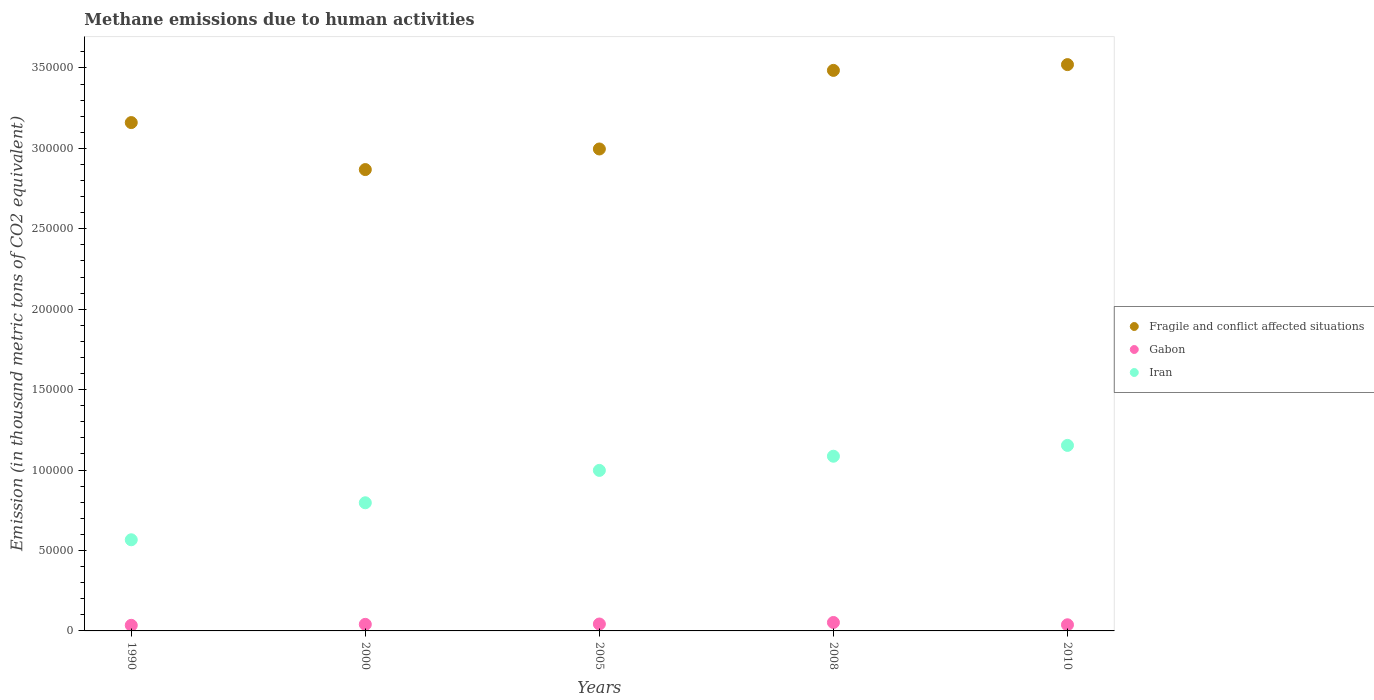Is the number of dotlines equal to the number of legend labels?
Offer a very short reply. Yes. What is the amount of methane emitted in Iran in 2000?
Provide a succinct answer. 7.97e+04. Across all years, what is the maximum amount of methane emitted in Iran?
Ensure brevity in your answer.  1.15e+05. Across all years, what is the minimum amount of methane emitted in Fragile and conflict affected situations?
Give a very brief answer. 2.87e+05. In which year was the amount of methane emitted in Iran maximum?
Your response must be concise. 2010. In which year was the amount of methane emitted in Fragile and conflict affected situations minimum?
Provide a succinct answer. 2000. What is the total amount of methane emitted in Gabon in the graph?
Your answer should be very brief. 2.09e+04. What is the difference between the amount of methane emitted in Fragile and conflict affected situations in 2000 and that in 2005?
Your answer should be very brief. -1.28e+04. What is the difference between the amount of methane emitted in Iran in 1990 and the amount of methane emitted in Gabon in 2008?
Give a very brief answer. 5.14e+04. What is the average amount of methane emitted in Gabon per year?
Your response must be concise. 4184.8. In the year 2008, what is the difference between the amount of methane emitted in Gabon and amount of methane emitted in Iran?
Your answer should be very brief. -1.03e+05. In how many years, is the amount of methane emitted in Iran greater than 200000 thousand metric tons?
Provide a short and direct response. 0. What is the ratio of the amount of methane emitted in Fragile and conflict affected situations in 1990 to that in 2010?
Your answer should be compact. 0.9. Is the amount of methane emitted in Iran in 2000 less than that in 2005?
Offer a very short reply. Yes. Is the difference between the amount of methane emitted in Gabon in 1990 and 2010 greater than the difference between the amount of methane emitted in Iran in 1990 and 2010?
Provide a short and direct response. Yes. What is the difference between the highest and the second highest amount of methane emitted in Iran?
Give a very brief answer. 6726.3. What is the difference between the highest and the lowest amount of methane emitted in Iran?
Keep it short and to the point. 5.87e+04. In how many years, is the amount of methane emitted in Fragile and conflict affected situations greater than the average amount of methane emitted in Fragile and conflict affected situations taken over all years?
Provide a succinct answer. 2. Is the sum of the amount of methane emitted in Fragile and conflict affected situations in 2005 and 2010 greater than the maximum amount of methane emitted in Iran across all years?
Your answer should be very brief. Yes. Is it the case that in every year, the sum of the amount of methane emitted in Fragile and conflict affected situations and amount of methane emitted in Iran  is greater than the amount of methane emitted in Gabon?
Make the answer very short. Yes. How many years are there in the graph?
Ensure brevity in your answer.  5. Does the graph contain any zero values?
Make the answer very short. No. Does the graph contain grids?
Provide a short and direct response. No. Where does the legend appear in the graph?
Your response must be concise. Center right. How many legend labels are there?
Your response must be concise. 3. How are the legend labels stacked?
Provide a succinct answer. Vertical. What is the title of the graph?
Provide a succinct answer. Methane emissions due to human activities. Does "Netherlands" appear as one of the legend labels in the graph?
Provide a succinct answer. No. What is the label or title of the Y-axis?
Give a very brief answer. Emission (in thousand metric tons of CO2 equivalent). What is the Emission (in thousand metric tons of CO2 equivalent) of Fragile and conflict affected situations in 1990?
Give a very brief answer. 3.16e+05. What is the Emission (in thousand metric tons of CO2 equivalent) in Gabon in 1990?
Offer a terse response. 3478.5. What is the Emission (in thousand metric tons of CO2 equivalent) in Iran in 1990?
Offer a terse response. 5.67e+04. What is the Emission (in thousand metric tons of CO2 equivalent) of Fragile and conflict affected situations in 2000?
Your answer should be compact. 2.87e+05. What is the Emission (in thousand metric tons of CO2 equivalent) in Gabon in 2000?
Offer a very short reply. 4082.1. What is the Emission (in thousand metric tons of CO2 equivalent) in Iran in 2000?
Keep it short and to the point. 7.97e+04. What is the Emission (in thousand metric tons of CO2 equivalent) of Fragile and conflict affected situations in 2005?
Offer a terse response. 3.00e+05. What is the Emission (in thousand metric tons of CO2 equivalent) of Gabon in 2005?
Make the answer very short. 4298.1. What is the Emission (in thousand metric tons of CO2 equivalent) of Iran in 2005?
Offer a terse response. 9.98e+04. What is the Emission (in thousand metric tons of CO2 equivalent) of Fragile and conflict affected situations in 2008?
Make the answer very short. 3.48e+05. What is the Emission (in thousand metric tons of CO2 equivalent) of Gabon in 2008?
Keep it short and to the point. 5247.8. What is the Emission (in thousand metric tons of CO2 equivalent) of Iran in 2008?
Provide a short and direct response. 1.09e+05. What is the Emission (in thousand metric tons of CO2 equivalent) of Fragile and conflict affected situations in 2010?
Give a very brief answer. 3.52e+05. What is the Emission (in thousand metric tons of CO2 equivalent) of Gabon in 2010?
Your answer should be very brief. 3817.5. What is the Emission (in thousand metric tons of CO2 equivalent) of Iran in 2010?
Keep it short and to the point. 1.15e+05. Across all years, what is the maximum Emission (in thousand metric tons of CO2 equivalent) in Fragile and conflict affected situations?
Your answer should be compact. 3.52e+05. Across all years, what is the maximum Emission (in thousand metric tons of CO2 equivalent) in Gabon?
Offer a terse response. 5247.8. Across all years, what is the maximum Emission (in thousand metric tons of CO2 equivalent) in Iran?
Provide a short and direct response. 1.15e+05. Across all years, what is the minimum Emission (in thousand metric tons of CO2 equivalent) in Fragile and conflict affected situations?
Provide a short and direct response. 2.87e+05. Across all years, what is the minimum Emission (in thousand metric tons of CO2 equivalent) of Gabon?
Offer a terse response. 3478.5. Across all years, what is the minimum Emission (in thousand metric tons of CO2 equivalent) in Iran?
Ensure brevity in your answer.  5.67e+04. What is the total Emission (in thousand metric tons of CO2 equivalent) in Fragile and conflict affected situations in the graph?
Offer a terse response. 1.60e+06. What is the total Emission (in thousand metric tons of CO2 equivalent) of Gabon in the graph?
Your response must be concise. 2.09e+04. What is the total Emission (in thousand metric tons of CO2 equivalent) of Iran in the graph?
Provide a succinct answer. 4.60e+05. What is the difference between the Emission (in thousand metric tons of CO2 equivalent) of Fragile and conflict affected situations in 1990 and that in 2000?
Ensure brevity in your answer.  2.92e+04. What is the difference between the Emission (in thousand metric tons of CO2 equivalent) in Gabon in 1990 and that in 2000?
Give a very brief answer. -603.6. What is the difference between the Emission (in thousand metric tons of CO2 equivalent) in Iran in 1990 and that in 2000?
Your answer should be compact. -2.30e+04. What is the difference between the Emission (in thousand metric tons of CO2 equivalent) of Fragile and conflict affected situations in 1990 and that in 2005?
Offer a very short reply. 1.64e+04. What is the difference between the Emission (in thousand metric tons of CO2 equivalent) of Gabon in 1990 and that in 2005?
Give a very brief answer. -819.6. What is the difference between the Emission (in thousand metric tons of CO2 equivalent) of Iran in 1990 and that in 2005?
Your answer should be compact. -4.31e+04. What is the difference between the Emission (in thousand metric tons of CO2 equivalent) of Fragile and conflict affected situations in 1990 and that in 2008?
Your answer should be compact. -3.24e+04. What is the difference between the Emission (in thousand metric tons of CO2 equivalent) of Gabon in 1990 and that in 2008?
Make the answer very short. -1769.3. What is the difference between the Emission (in thousand metric tons of CO2 equivalent) of Iran in 1990 and that in 2008?
Ensure brevity in your answer.  -5.19e+04. What is the difference between the Emission (in thousand metric tons of CO2 equivalent) in Fragile and conflict affected situations in 1990 and that in 2010?
Make the answer very short. -3.60e+04. What is the difference between the Emission (in thousand metric tons of CO2 equivalent) in Gabon in 1990 and that in 2010?
Provide a short and direct response. -339. What is the difference between the Emission (in thousand metric tons of CO2 equivalent) in Iran in 1990 and that in 2010?
Your response must be concise. -5.87e+04. What is the difference between the Emission (in thousand metric tons of CO2 equivalent) of Fragile and conflict affected situations in 2000 and that in 2005?
Provide a succinct answer. -1.28e+04. What is the difference between the Emission (in thousand metric tons of CO2 equivalent) of Gabon in 2000 and that in 2005?
Give a very brief answer. -216. What is the difference between the Emission (in thousand metric tons of CO2 equivalent) of Iran in 2000 and that in 2005?
Keep it short and to the point. -2.01e+04. What is the difference between the Emission (in thousand metric tons of CO2 equivalent) of Fragile and conflict affected situations in 2000 and that in 2008?
Your answer should be very brief. -6.17e+04. What is the difference between the Emission (in thousand metric tons of CO2 equivalent) of Gabon in 2000 and that in 2008?
Provide a short and direct response. -1165.7. What is the difference between the Emission (in thousand metric tons of CO2 equivalent) of Iran in 2000 and that in 2008?
Provide a short and direct response. -2.89e+04. What is the difference between the Emission (in thousand metric tons of CO2 equivalent) in Fragile and conflict affected situations in 2000 and that in 2010?
Offer a very short reply. -6.53e+04. What is the difference between the Emission (in thousand metric tons of CO2 equivalent) of Gabon in 2000 and that in 2010?
Make the answer very short. 264.6. What is the difference between the Emission (in thousand metric tons of CO2 equivalent) of Iran in 2000 and that in 2010?
Provide a succinct answer. -3.57e+04. What is the difference between the Emission (in thousand metric tons of CO2 equivalent) in Fragile and conflict affected situations in 2005 and that in 2008?
Your answer should be compact. -4.89e+04. What is the difference between the Emission (in thousand metric tons of CO2 equivalent) of Gabon in 2005 and that in 2008?
Your response must be concise. -949.7. What is the difference between the Emission (in thousand metric tons of CO2 equivalent) of Iran in 2005 and that in 2008?
Offer a terse response. -8816.1. What is the difference between the Emission (in thousand metric tons of CO2 equivalent) of Fragile and conflict affected situations in 2005 and that in 2010?
Your answer should be very brief. -5.24e+04. What is the difference between the Emission (in thousand metric tons of CO2 equivalent) in Gabon in 2005 and that in 2010?
Your answer should be very brief. 480.6. What is the difference between the Emission (in thousand metric tons of CO2 equivalent) in Iran in 2005 and that in 2010?
Your answer should be very brief. -1.55e+04. What is the difference between the Emission (in thousand metric tons of CO2 equivalent) of Fragile and conflict affected situations in 2008 and that in 2010?
Make the answer very short. -3591.7. What is the difference between the Emission (in thousand metric tons of CO2 equivalent) in Gabon in 2008 and that in 2010?
Your response must be concise. 1430.3. What is the difference between the Emission (in thousand metric tons of CO2 equivalent) of Iran in 2008 and that in 2010?
Provide a short and direct response. -6726.3. What is the difference between the Emission (in thousand metric tons of CO2 equivalent) of Fragile and conflict affected situations in 1990 and the Emission (in thousand metric tons of CO2 equivalent) of Gabon in 2000?
Make the answer very short. 3.12e+05. What is the difference between the Emission (in thousand metric tons of CO2 equivalent) of Fragile and conflict affected situations in 1990 and the Emission (in thousand metric tons of CO2 equivalent) of Iran in 2000?
Make the answer very short. 2.36e+05. What is the difference between the Emission (in thousand metric tons of CO2 equivalent) in Gabon in 1990 and the Emission (in thousand metric tons of CO2 equivalent) in Iran in 2000?
Make the answer very short. -7.62e+04. What is the difference between the Emission (in thousand metric tons of CO2 equivalent) in Fragile and conflict affected situations in 1990 and the Emission (in thousand metric tons of CO2 equivalent) in Gabon in 2005?
Your answer should be compact. 3.12e+05. What is the difference between the Emission (in thousand metric tons of CO2 equivalent) in Fragile and conflict affected situations in 1990 and the Emission (in thousand metric tons of CO2 equivalent) in Iran in 2005?
Provide a succinct answer. 2.16e+05. What is the difference between the Emission (in thousand metric tons of CO2 equivalent) of Gabon in 1990 and the Emission (in thousand metric tons of CO2 equivalent) of Iran in 2005?
Make the answer very short. -9.63e+04. What is the difference between the Emission (in thousand metric tons of CO2 equivalent) of Fragile and conflict affected situations in 1990 and the Emission (in thousand metric tons of CO2 equivalent) of Gabon in 2008?
Your answer should be very brief. 3.11e+05. What is the difference between the Emission (in thousand metric tons of CO2 equivalent) in Fragile and conflict affected situations in 1990 and the Emission (in thousand metric tons of CO2 equivalent) in Iran in 2008?
Keep it short and to the point. 2.07e+05. What is the difference between the Emission (in thousand metric tons of CO2 equivalent) of Gabon in 1990 and the Emission (in thousand metric tons of CO2 equivalent) of Iran in 2008?
Your answer should be compact. -1.05e+05. What is the difference between the Emission (in thousand metric tons of CO2 equivalent) in Fragile and conflict affected situations in 1990 and the Emission (in thousand metric tons of CO2 equivalent) in Gabon in 2010?
Make the answer very short. 3.12e+05. What is the difference between the Emission (in thousand metric tons of CO2 equivalent) in Fragile and conflict affected situations in 1990 and the Emission (in thousand metric tons of CO2 equivalent) in Iran in 2010?
Your answer should be compact. 2.01e+05. What is the difference between the Emission (in thousand metric tons of CO2 equivalent) in Gabon in 1990 and the Emission (in thousand metric tons of CO2 equivalent) in Iran in 2010?
Offer a very short reply. -1.12e+05. What is the difference between the Emission (in thousand metric tons of CO2 equivalent) of Fragile and conflict affected situations in 2000 and the Emission (in thousand metric tons of CO2 equivalent) of Gabon in 2005?
Your response must be concise. 2.83e+05. What is the difference between the Emission (in thousand metric tons of CO2 equivalent) of Fragile and conflict affected situations in 2000 and the Emission (in thousand metric tons of CO2 equivalent) of Iran in 2005?
Give a very brief answer. 1.87e+05. What is the difference between the Emission (in thousand metric tons of CO2 equivalent) in Gabon in 2000 and the Emission (in thousand metric tons of CO2 equivalent) in Iran in 2005?
Provide a succinct answer. -9.57e+04. What is the difference between the Emission (in thousand metric tons of CO2 equivalent) of Fragile and conflict affected situations in 2000 and the Emission (in thousand metric tons of CO2 equivalent) of Gabon in 2008?
Your answer should be compact. 2.82e+05. What is the difference between the Emission (in thousand metric tons of CO2 equivalent) of Fragile and conflict affected situations in 2000 and the Emission (in thousand metric tons of CO2 equivalent) of Iran in 2008?
Make the answer very short. 1.78e+05. What is the difference between the Emission (in thousand metric tons of CO2 equivalent) of Gabon in 2000 and the Emission (in thousand metric tons of CO2 equivalent) of Iran in 2008?
Give a very brief answer. -1.05e+05. What is the difference between the Emission (in thousand metric tons of CO2 equivalent) in Fragile and conflict affected situations in 2000 and the Emission (in thousand metric tons of CO2 equivalent) in Gabon in 2010?
Make the answer very short. 2.83e+05. What is the difference between the Emission (in thousand metric tons of CO2 equivalent) of Fragile and conflict affected situations in 2000 and the Emission (in thousand metric tons of CO2 equivalent) of Iran in 2010?
Keep it short and to the point. 1.71e+05. What is the difference between the Emission (in thousand metric tons of CO2 equivalent) of Gabon in 2000 and the Emission (in thousand metric tons of CO2 equivalent) of Iran in 2010?
Ensure brevity in your answer.  -1.11e+05. What is the difference between the Emission (in thousand metric tons of CO2 equivalent) of Fragile and conflict affected situations in 2005 and the Emission (in thousand metric tons of CO2 equivalent) of Gabon in 2008?
Provide a short and direct response. 2.94e+05. What is the difference between the Emission (in thousand metric tons of CO2 equivalent) in Fragile and conflict affected situations in 2005 and the Emission (in thousand metric tons of CO2 equivalent) in Iran in 2008?
Ensure brevity in your answer.  1.91e+05. What is the difference between the Emission (in thousand metric tons of CO2 equivalent) of Gabon in 2005 and the Emission (in thousand metric tons of CO2 equivalent) of Iran in 2008?
Provide a short and direct response. -1.04e+05. What is the difference between the Emission (in thousand metric tons of CO2 equivalent) of Fragile and conflict affected situations in 2005 and the Emission (in thousand metric tons of CO2 equivalent) of Gabon in 2010?
Your answer should be very brief. 2.96e+05. What is the difference between the Emission (in thousand metric tons of CO2 equivalent) in Fragile and conflict affected situations in 2005 and the Emission (in thousand metric tons of CO2 equivalent) in Iran in 2010?
Offer a terse response. 1.84e+05. What is the difference between the Emission (in thousand metric tons of CO2 equivalent) in Gabon in 2005 and the Emission (in thousand metric tons of CO2 equivalent) in Iran in 2010?
Your answer should be very brief. -1.11e+05. What is the difference between the Emission (in thousand metric tons of CO2 equivalent) in Fragile and conflict affected situations in 2008 and the Emission (in thousand metric tons of CO2 equivalent) in Gabon in 2010?
Offer a terse response. 3.45e+05. What is the difference between the Emission (in thousand metric tons of CO2 equivalent) of Fragile and conflict affected situations in 2008 and the Emission (in thousand metric tons of CO2 equivalent) of Iran in 2010?
Offer a very short reply. 2.33e+05. What is the difference between the Emission (in thousand metric tons of CO2 equivalent) in Gabon in 2008 and the Emission (in thousand metric tons of CO2 equivalent) in Iran in 2010?
Ensure brevity in your answer.  -1.10e+05. What is the average Emission (in thousand metric tons of CO2 equivalent) in Fragile and conflict affected situations per year?
Give a very brief answer. 3.21e+05. What is the average Emission (in thousand metric tons of CO2 equivalent) in Gabon per year?
Your answer should be compact. 4184.8. What is the average Emission (in thousand metric tons of CO2 equivalent) of Iran per year?
Provide a succinct answer. 9.20e+04. In the year 1990, what is the difference between the Emission (in thousand metric tons of CO2 equivalent) of Fragile and conflict affected situations and Emission (in thousand metric tons of CO2 equivalent) of Gabon?
Provide a succinct answer. 3.13e+05. In the year 1990, what is the difference between the Emission (in thousand metric tons of CO2 equivalent) in Fragile and conflict affected situations and Emission (in thousand metric tons of CO2 equivalent) in Iran?
Ensure brevity in your answer.  2.59e+05. In the year 1990, what is the difference between the Emission (in thousand metric tons of CO2 equivalent) of Gabon and Emission (in thousand metric tons of CO2 equivalent) of Iran?
Your response must be concise. -5.32e+04. In the year 2000, what is the difference between the Emission (in thousand metric tons of CO2 equivalent) in Fragile and conflict affected situations and Emission (in thousand metric tons of CO2 equivalent) in Gabon?
Make the answer very short. 2.83e+05. In the year 2000, what is the difference between the Emission (in thousand metric tons of CO2 equivalent) in Fragile and conflict affected situations and Emission (in thousand metric tons of CO2 equivalent) in Iran?
Your answer should be very brief. 2.07e+05. In the year 2000, what is the difference between the Emission (in thousand metric tons of CO2 equivalent) of Gabon and Emission (in thousand metric tons of CO2 equivalent) of Iran?
Give a very brief answer. -7.56e+04. In the year 2005, what is the difference between the Emission (in thousand metric tons of CO2 equivalent) of Fragile and conflict affected situations and Emission (in thousand metric tons of CO2 equivalent) of Gabon?
Provide a succinct answer. 2.95e+05. In the year 2005, what is the difference between the Emission (in thousand metric tons of CO2 equivalent) of Fragile and conflict affected situations and Emission (in thousand metric tons of CO2 equivalent) of Iran?
Your answer should be very brief. 2.00e+05. In the year 2005, what is the difference between the Emission (in thousand metric tons of CO2 equivalent) in Gabon and Emission (in thousand metric tons of CO2 equivalent) in Iran?
Your answer should be compact. -9.55e+04. In the year 2008, what is the difference between the Emission (in thousand metric tons of CO2 equivalent) of Fragile and conflict affected situations and Emission (in thousand metric tons of CO2 equivalent) of Gabon?
Keep it short and to the point. 3.43e+05. In the year 2008, what is the difference between the Emission (in thousand metric tons of CO2 equivalent) in Fragile and conflict affected situations and Emission (in thousand metric tons of CO2 equivalent) in Iran?
Offer a terse response. 2.40e+05. In the year 2008, what is the difference between the Emission (in thousand metric tons of CO2 equivalent) in Gabon and Emission (in thousand metric tons of CO2 equivalent) in Iran?
Your answer should be compact. -1.03e+05. In the year 2010, what is the difference between the Emission (in thousand metric tons of CO2 equivalent) of Fragile and conflict affected situations and Emission (in thousand metric tons of CO2 equivalent) of Gabon?
Offer a very short reply. 3.48e+05. In the year 2010, what is the difference between the Emission (in thousand metric tons of CO2 equivalent) in Fragile and conflict affected situations and Emission (in thousand metric tons of CO2 equivalent) in Iran?
Provide a short and direct response. 2.37e+05. In the year 2010, what is the difference between the Emission (in thousand metric tons of CO2 equivalent) in Gabon and Emission (in thousand metric tons of CO2 equivalent) in Iran?
Provide a succinct answer. -1.12e+05. What is the ratio of the Emission (in thousand metric tons of CO2 equivalent) in Fragile and conflict affected situations in 1990 to that in 2000?
Your answer should be very brief. 1.1. What is the ratio of the Emission (in thousand metric tons of CO2 equivalent) in Gabon in 1990 to that in 2000?
Offer a very short reply. 0.85. What is the ratio of the Emission (in thousand metric tons of CO2 equivalent) in Iran in 1990 to that in 2000?
Keep it short and to the point. 0.71. What is the ratio of the Emission (in thousand metric tons of CO2 equivalent) in Fragile and conflict affected situations in 1990 to that in 2005?
Your answer should be very brief. 1.05. What is the ratio of the Emission (in thousand metric tons of CO2 equivalent) in Gabon in 1990 to that in 2005?
Provide a short and direct response. 0.81. What is the ratio of the Emission (in thousand metric tons of CO2 equivalent) of Iran in 1990 to that in 2005?
Offer a terse response. 0.57. What is the ratio of the Emission (in thousand metric tons of CO2 equivalent) of Fragile and conflict affected situations in 1990 to that in 2008?
Your answer should be very brief. 0.91. What is the ratio of the Emission (in thousand metric tons of CO2 equivalent) in Gabon in 1990 to that in 2008?
Your answer should be compact. 0.66. What is the ratio of the Emission (in thousand metric tons of CO2 equivalent) in Iran in 1990 to that in 2008?
Your answer should be compact. 0.52. What is the ratio of the Emission (in thousand metric tons of CO2 equivalent) in Fragile and conflict affected situations in 1990 to that in 2010?
Offer a terse response. 0.9. What is the ratio of the Emission (in thousand metric tons of CO2 equivalent) of Gabon in 1990 to that in 2010?
Give a very brief answer. 0.91. What is the ratio of the Emission (in thousand metric tons of CO2 equivalent) in Iran in 1990 to that in 2010?
Your response must be concise. 0.49. What is the ratio of the Emission (in thousand metric tons of CO2 equivalent) of Fragile and conflict affected situations in 2000 to that in 2005?
Keep it short and to the point. 0.96. What is the ratio of the Emission (in thousand metric tons of CO2 equivalent) of Gabon in 2000 to that in 2005?
Provide a short and direct response. 0.95. What is the ratio of the Emission (in thousand metric tons of CO2 equivalent) of Iran in 2000 to that in 2005?
Provide a succinct answer. 0.8. What is the ratio of the Emission (in thousand metric tons of CO2 equivalent) in Fragile and conflict affected situations in 2000 to that in 2008?
Keep it short and to the point. 0.82. What is the ratio of the Emission (in thousand metric tons of CO2 equivalent) in Gabon in 2000 to that in 2008?
Your answer should be compact. 0.78. What is the ratio of the Emission (in thousand metric tons of CO2 equivalent) of Iran in 2000 to that in 2008?
Offer a terse response. 0.73. What is the ratio of the Emission (in thousand metric tons of CO2 equivalent) in Fragile and conflict affected situations in 2000 to that in 2010?
Offer a terse response. 0.81. What is the ratio of the Emission (in thousand metric tons of CO2 equivalent) of Gabon in 2000 to that in 2010?
Your answer should be very brief. 1.07. What is the ratio of the Emission (in thousand metric tons of CO2 equivalent) in Iran in 2000 to that in 2010?
Give a very brief answer. 0.69. What is the ratio of the Emission (in thousand metric tons of CO2 equivalent) of Fragile and conflict affected situations in 2005 to that in 2008?
Give a very brief answer. 0.86. What is the ratio of the Emission (in thousand metric tons of CO2 equivalent) in Gabon in 2005 to that in 2008?
Provide a succinct answer. 0.82. What is the ratio of the Emission (in thousand metric tons of CO2 equivalent) of Iran in 2005 to that in 2008?
Offer a very short reply. 0.92. What is the ratio of the Emission (in thousand metric tons of CO2 equivalent) in Fragile and conflict affected situations in 2005 to that in 2010?
Provide a short and direct response. 0.85. What is the ratio of the Emission (in thousand metric tons of CO2 equivalent) in Gabon in 2005 to that in 2010?
Make the answer very short. 1.13. What is the ratio of the Emission (in thousand metric tons of CO2 equivalent) in Iran in 2005 to that in 2010?
Offer a terse response. 0.87. What is the ratio of the Emission (in thousand metric tons of CO2 equivalent) in Fragile and conflict affected situations in 2008 to that in 2010?
Keep it short and to the point. 0.99. What is the ratio of the Emission (in thousand metric tons of CO2 equivalent) in Gabon in 2008 to that in 2010?
Ensure brevity in your answer.  1.37. What is the ratio of the Emission (in thousand metric tons of CO2 equivalent) of Iran in 2008 to that in 2010?
Provide a short and direct response. 0.94. What is the difference between the highest and the second highest Emission (in thousand metric tons of CO2 equivalent) of Fragile and conflict affected situations?
Offer a terse response. 3591.7. What is the difference between the highest and the second highest Emission (in thousand metric tons of CO2 equivalent) in Gabon?
Offer a terse response. 949.7. What is the difference between the highest and the second highest Emission (in thousand metric tons of CO2 equivalent) in Iran?
Ensure brevity in your answer.  6726.3. What is the difference between the highest and the lowest Emission (in thousand metric tons of CO2 equivalent) of Fragile and conflict affected situations?
Ensure brevity in your answer.  6.53e+04. What is the difference between the highest and the lowest Emission (in thousand metric tons of CO2 equivalent) of Gabon?
Make the answer very short. 1769.3. What is the difference between the highest and the lowest Emission (in thousand metric tons of CO2 equivalent) of Iran?
Your answer should be very brief. 5.87e+04. 